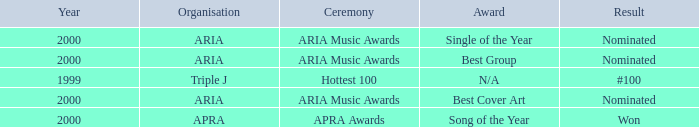What were the results before the year 2000? #100. Help me parse the entirety of this table. {'header': ['Year', 'Organisation', 'Ceremony', 'Award', 'Result'], 'rows': [['2000', 'ARIA', 'ARIA Music Awards', 'Single of the Year', 'Nominated'], ['2000', 'ARIA', 'ARIA Music Awards', 'Best Group', 'Nominated'], ['1999', 'Triple J', 'Hottest 100', 'N/A', '#100'], ['2000', 'ARIA', 'ARIA Music Awards', 'Best Cover Art', 'Nominated'], ['2000', 'APRA', 'APRA Awards', 'Song of the Year', 'Won']]} 